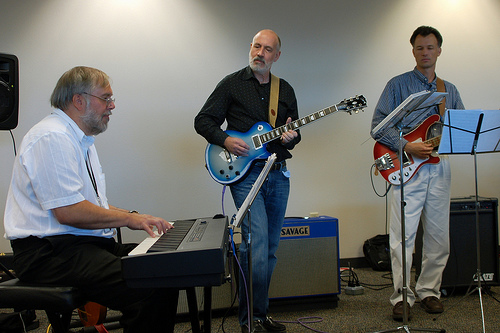<image>
Is there a man behind the speaker? No. The man is not behind the speaker. From this viewpoint, the man appears to be positioned elsewhere in the scene. Where is the guitar in relation to the man? Is it on the man? No. The guitar is not positioned on the man. They may be near each other, but the guitar is not supported by or resting on top of the man. Is the keyboard in front of the speaker? Yes. The keyboard is positioned in front of the speaker, appearing closer to the camera viewpoint. 